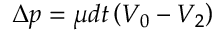<formula> <loc_0><loc_0><loc_500><loc_500>\Delta p = \mu d t \left ( V _ { 0 } - V _ { 2 } \right )</formula> 